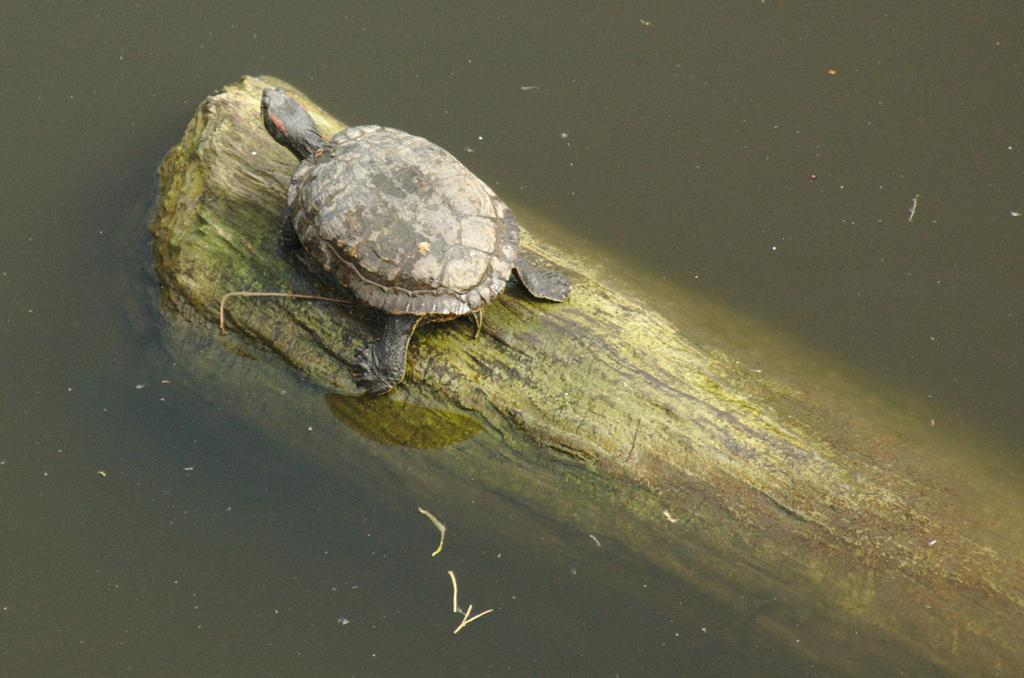What animal is present in the image? There is a tortoise in the image. What is the tortoise standing on? The tortoise is standing on a wooden object. Where is the wooden object located? The wooden object is in a water body. What type of education does the tortoise have in the image? There is no indication of the tortoise's education in the image. 